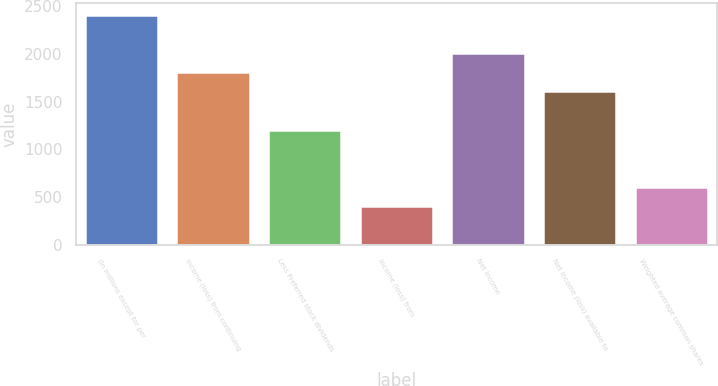<chart> <loc_0><loc_0><loc_500><loc_500><bar_chart><fcel>(In millions except for per<fcel>Income (loss) from continuing<fcel>Less Preferred stock dividends<fcel>Income (loss) from<fcel>Net income<fcel>Net income (loss) available to<fcel>Weighted average common shares<nl><fcel>2411.5<fcel>1809.28<fcel>1207.06<fcel>404.1<fcel>2010.02<fcel>1608.54<fcel>604.84<nl></chart> 